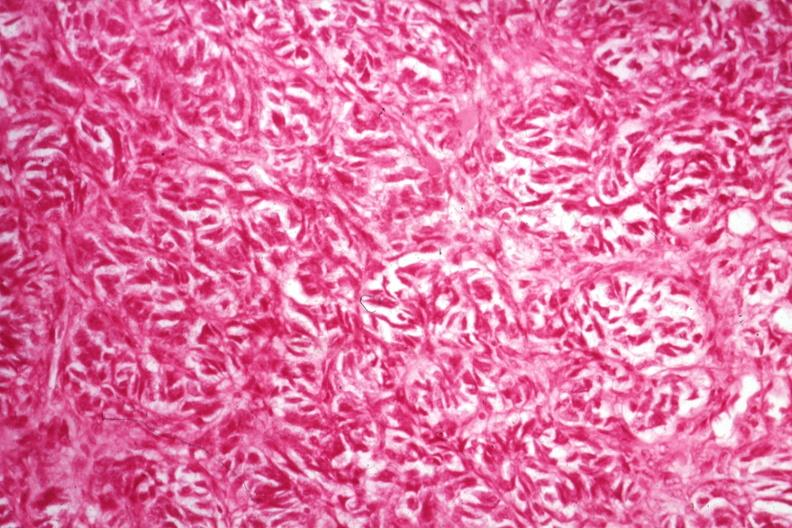what is present?
Answer the question using a single word or phrase. Ovary 